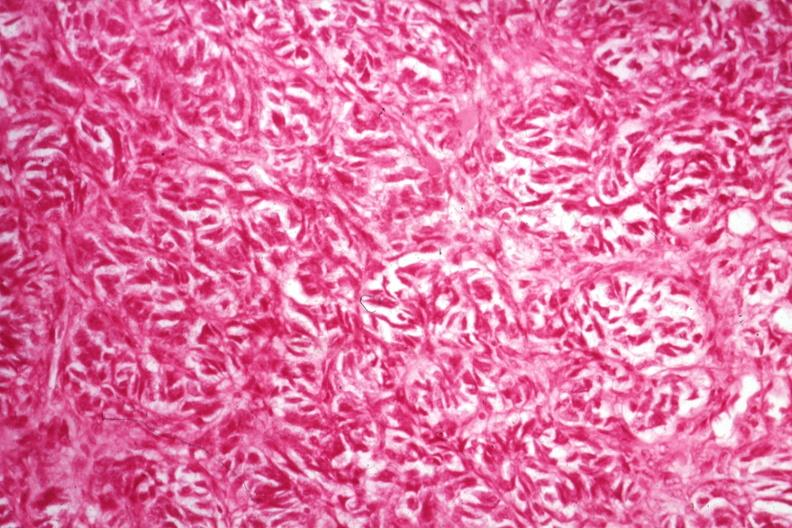what is present?
Answer the question using a single word or phrase. Ovary 